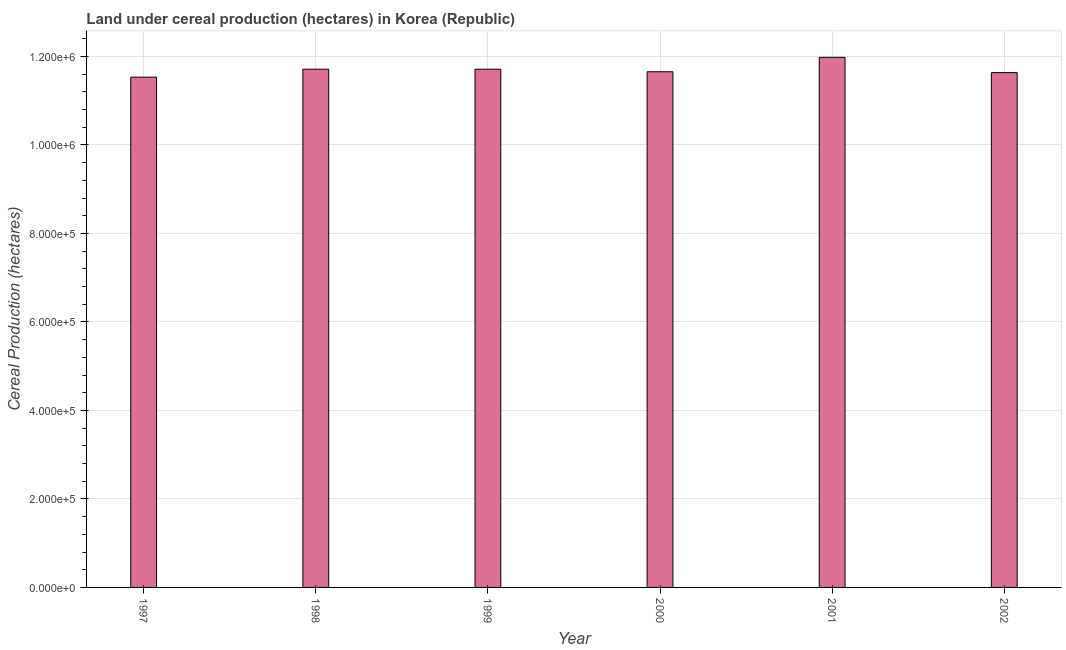Does the graph contain any zero values?
Provide a succinct answer. No. Does the graph contain grids?
Make the answer very short. Yes. What is the title of the graph?
Your answer should be very brief. Land under cereal production (hectares) in Korea (Republic). What is the label or title of the Y-axis?
Make the answer very short. Cereal Production (hectares). What is the land under cereal production in 1999?
Keep it short and to the point. 1.17e+06. Across all years, what is the maximum land under cereal production?
Ensure brevity in your answer.  1.20e+06. Across all years, what is the minimum land under cereal production?
Give a very brief answer. 1.15e+06. In which year was the land under cereal production maximum?
Provide a short and direct response. 2001. In which year was the land under cereal production minimum?
Your answer should be compact. 1997. What is the sum of the land under cereal production?
Your answer should be compact. 7.02e+06. What is the average land under cereal production per year?
Ensure brevity in your answer.  1.17e+06. What is the median land under cereal production?
Offer a terse response. 1.17e+06. In how many years, is the land under cereal production greater than 480000 hectares?
Give a very brief answer. 6. Do a majority of the years between 1998 and 2001 (inclusive) have land under cereal production greater than 1040000 hectares?
Offer a terse response. Yes. Is the difference between the land under cereal production in 1997 and 2000 greater than the difference between any two years?
Give a very brief answer. No. What is the difference between the highest and the second highest land under cereal production?
Your answer should be compact. 2.67e+04. What is the difference between the highest and the lowest land under cereal production?
Provide a succinct answer. 4.48e+04. Are all the bars in the graph horizontal?
Your response must be concise. No. How many years are there in the graph?
Ensure brevity in your answer.  6. Are the values on the major ticks of Y-axis written in scientific E-notation?
Keep it short and to the point. Yes. What is the Cereal Production (hectares) in 1997?
Make the answer very short. 1.15e+06. What is the Cereal Production (hectares) in 1998?
Give a very brief answer. 1.17e+06. What is the Cereal Production (hectares) in 1999?
Your response must be concise. 1.17e+06. What is the Cereal Production (hectares) of 2000?
Offer a terse response. 1.17e+06. What is the Cereal Production (hectares) of 2001?
Keep it short and to the point. 1.20e+06. What is the Cereal Production (hectares) of 2002?
Ensure brevity in your answer.  1.16e+06. What is the difference between the Cereal Production (hectares) in 1997 and 1998?
Ensure brevity in your answer.  -1.80e+04. What is the difference between the Cereal Production (hectares) in 1997 and 1999?
Offer a terse response. -1.80e+04. What is the difference between the Cereal Production (hectares) in 1997 and 2000?
Your answer should be very brief. -1.21e+04. What is the difference between the Cereal Production (hectares) in 1997 and 2001?
Give a very brief answer. -4.48e+04. What is the difference between the Cereal Production (hectares) in 1997 and 2002?
Provide a short and direct response. -1.02e+04. What is the difference between the Cereal Production (hectares) in 1998 and 1999?
Provide a succinct answer. 34. What is the difference between the Cereal Production (hectares) in 1998 and 2000?
Your answer should be very brief. 5884. What is the difference between the Cereal Production (hectares) in 1998 and 2001?
Make the answer very short. -2.67e+04. What is the difference between the Cereal Production (hectares) in 1998 and 2002?
Provide a succinct answer. 7796. What is the difference between the Cereal Production (hectares) in 1999 and 2000?
Offer a very short reply. 5850. What is the difference between the Cereal Production (hectares) in 1999 and 2001?
Provide a short and direct response. -2.68e+04. What is the difference between the Cereal Production (hectares) in 1999 and 2002?
Keep it short and to the point. 7762. What is the difference between the Cereal Production (hectares) in 2000 and 2001?
Give a very brief answer. -3.26e+04. What is the difference between the Cereal Production (hectares) in 2000 and 2002?
Keep it short and to the point. 1912. What is the difference between the Cereal Production (hectares) in 2001 and 2002?
Provide a succinct answer. 3.45e+04. What is the ratio of the Cereal Production (hectares) in 1997 to that in 1998?
Your answer should be very brief. 0.98. What is the ratio of the Cereal Production (hectares) in 1997 to that in 1999?
Your answer should be compact. 0.98. What is the ratio of the Cereal Production (hectares) in 1997 to that in 2002?
Your answer should be compact. 0.99. What is the ratio of the Cereal Production (hectares) in 1998 to that in 2000?
Give a very brief answer. 1. What is the ratio of the Cereal Production (hectares) in 1998 to that in 2002?
Ensure brevity in your answer.  1.01. What is the ratio of the Cereal Production (hectares) in 2000 to that in 2001?
Make the answer very short. 0.97. What is the ratio of the Cereal Production (hectares) in 2001 to that in 2002?
Offer a very short reply. 1.03. 